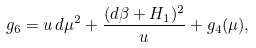<formula> <loc_0><loc_0><loc_500><loc_500>g _ { 6 } = u \, d \mu ^ { 2 } + \frac { ( d \beta + H _ { 1 } ) ^ { 2 } } { u } + g _ { 4 } ( \mu ) ,</formula> 